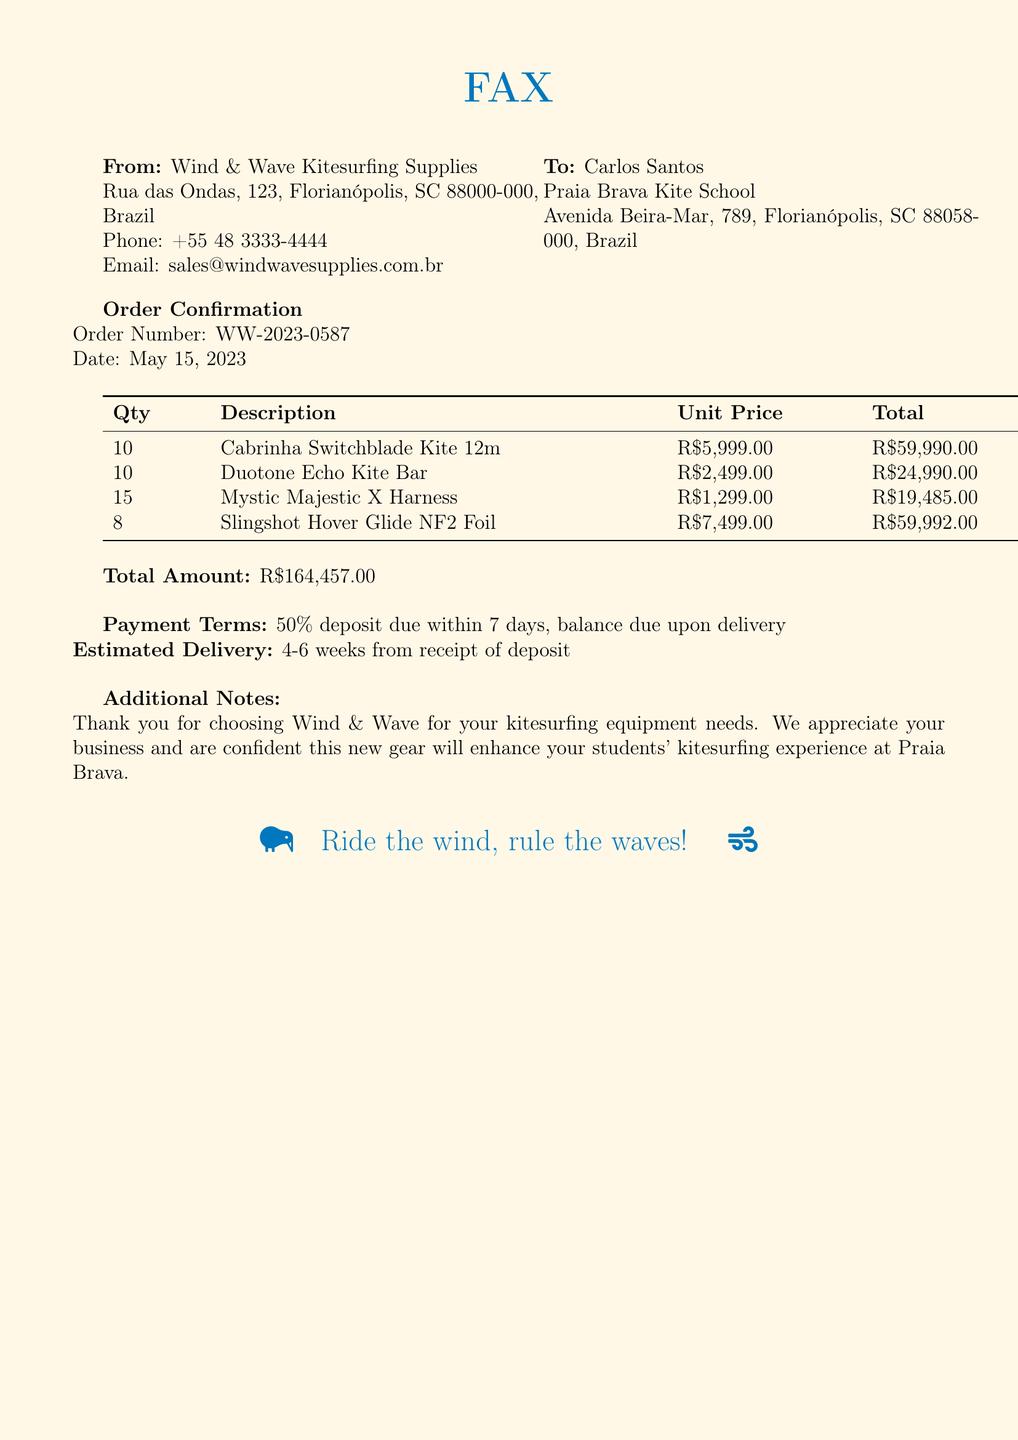What is the order number? The order number is explicitly stated in the document, making it straightforward to retrieve.
Answer: WW-2023-0587 What is the total amount? The total amount is clearly indicated at the end of the order confirmation section.
Answer: R$164,457.00 Who is the recipient of the fax? The recipient's name and school are mentioned at the beginning of the fax.
Answer: Carlos Santos What is the quantity of Mystic Majestic X Harnesses ordered? The quantity is specified in the order table for that particular item.
Answer: 15 What are the payment terms? The payment terms are outlined in the document, detailing the deposit and balance payment.
Answer: 50% deposit due within 7 days, balance due upon delivery What is the estimated delivery time? The estimated delivery is stated in the additional notes section.
Answer: 4-6 weeks from receipt of deposit What is the unit price of the Cabrinha Switchblade Kite 12m? The unit price is provided in the order table under the description of the item.
Answer: R$5,999.00 What type of document is this? The content and formatting of the document indicate its nature and purpose.
Answer: Fax What does the additional note thank Carlos for? The additional note expresses gratitude for the customer's choice regarding kitesurfing equipment.
Answer: Thank you for choosing Wind & Wave for your kitesurfing equipment needs 